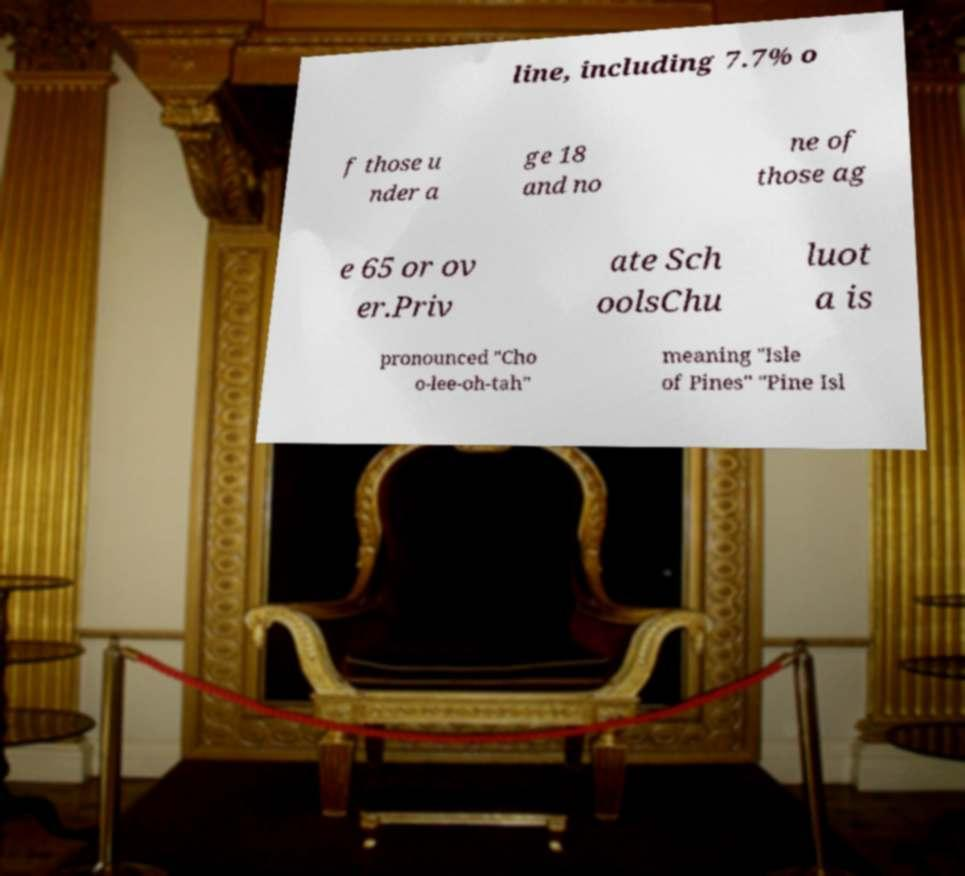There's text embedded in this image that I need extracted. Can you transcribe it verbatim? line, including 7.7% o f those u nder a ge 18 and no ne of those ag e 65 or ov er.Priv ate Sch oolsChu luot a is pronounced "Cho o-lee-oh-tah" meaning "Isle of Pines" "Pine Isl 